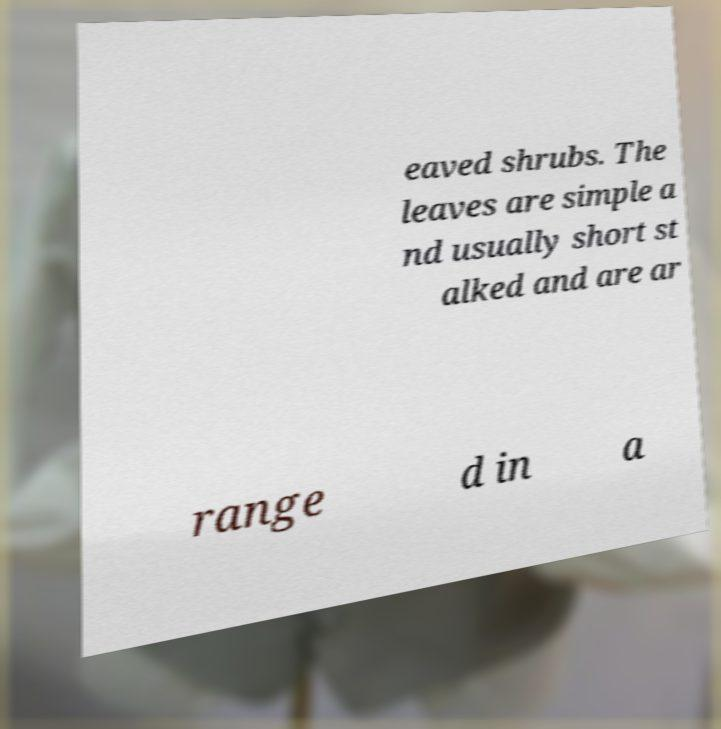Could you extract and type out the text from this image? eaved shrubs. The leaves are simple a nd usually short st alked and are ar range d in a 